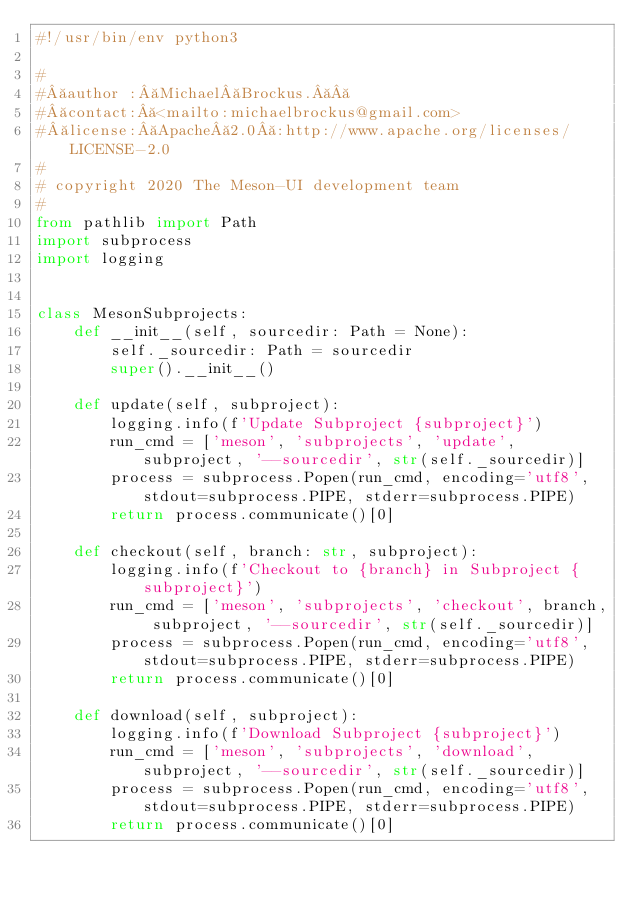Convert code to text. <code><loc_0><loc_0><loc_500><loc_500><_Python_>#!/usr/bin/env python3

#
# author : Michael Brockus.  
# contact: <mailto:michaelbrockus@gmail.com>
# license: Apache 2.0 :http://www.apache.org/licenses/LICENSE-2.0
#
# copyright 2020 The Meson-UI development team
#
from pathlib import Path
import subprocess
import logging


class MesonSubprojects:
    def __init__(self, sourcedir: Path = None):
        self._sourcedir: Path = sourcedir
        super().__init__()

    def update(self, subproject):
        logging.info(f'Update Subproject {subproject}')
        run_cmd = ['meson', 'subprojects', 'update', subproject, '--sourcedir', str(self._sourcedir)]
        process = subprocess.Popen(run_cmd, encoding='utf8', stdout=subprocess.PIPE, stderr=subprocess.PIPE)
        return process.communicate()[0]

    def checkout(self, branch: str, subproject):
        logging.info(f'Checkout to {branch} in Subproject {subproject}')
        run_cmd = ['meson', 'subprojects', 'checkout', branch, subproject, '--sourcedir', str(self._sourcedir)]
        process = subprocess.Popen(run_cmd, encoding='utf8', stdout=subprocess.PIPE, stderr=subprocess.PIPE)
        return process.communicate()[0]

    def download(self, subproject):
        logging.info(f'Download Subproject {subproject}')
        run_cmd = ['meson', 'subprojects', 'download', subproject, '--sourcedir', str(self._sourcedir)]
        process = subprocess.Popen(run_cmd, encoding='utf8', stdout=subprocess.PIPE, stderr=subprocess.PIPE)
        return process.communicate()[0]
</code> 